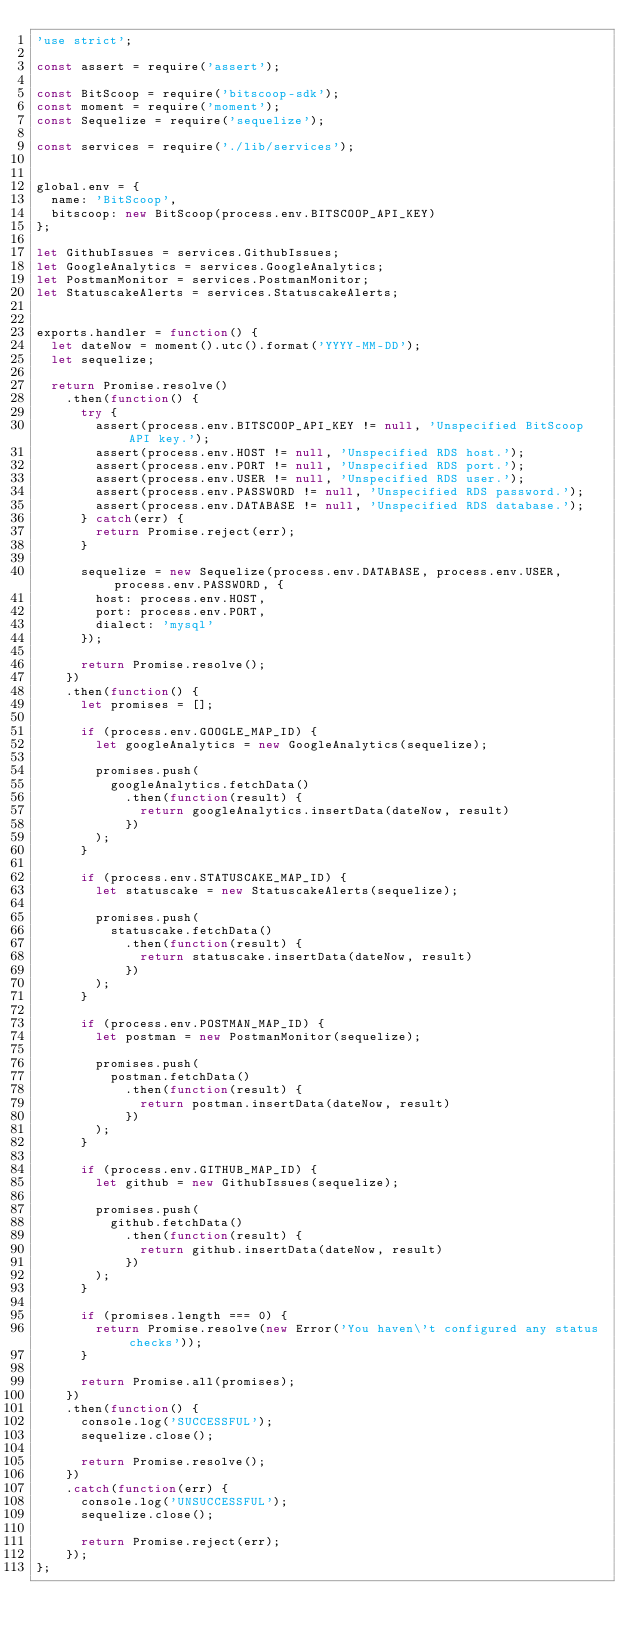<code> <loc_0><loc_0><loc_500><loc_500><_JavaScript_>'use strict';

const assert = require('assert');

const BitScoop = require('bitscoop-sdk');
const moment = require('moment');
const Sequelize = require('sequelize');

const services = require('./lib/services');


global.env = {
	name: 'BitScoop',
	bitscoop: new BitScoop(process.env.BITSCOOP_API_KEY)
};

let GithubIssues = services.GithubIssues;
let GoogleAnalytics = services.GoogleAnalytics;
let PostmanMonitor = services.PostmanMonitor;
let StatuscakeAlerts = services.StatuscakeAlerts;


exports.handler = function() {
	let dateNow = moment().utc().format('YYYY-MM-DD');
	let sequelize;

	return Promise.resolve()
		.then(function() {
			try {
				assert(process.env.BITSCOOP_API_KEY != null, 'Unspecified BitScoop API key.');
				assert(process.env.HOST != null, 'Unspecified RDS host.');
				assert(process.env.PORT != null, 'Unspecified RDS port.');
				assert(process.env.USER != null, 'Unspecified RDS user.');
				assert(process.env.PASSWORD != null, 'Unspecified RDS password.');
				assert(process.env.DATABASE != null, 'Unspecified RDS database.');
			} catch(err) {
				return Promise.reject(err);
			}

			sequelize = new Sequelize(process.env.DATABASE, process.env.USER, process.env.PASSWORD, {
				host: process.env.HOST,
				port: process.env.PORT,
				dialect: 'mysql'
			});

			return Promise.resolve();
		})
		.then(function() {
			let promises = [];

			if (process.env.GOOGLE_MAP_ID) {
				let googleAnalytics = new GoogleAnalytics(sequelize);

				promises.push(
					googleAnalytics.fetchData()
						.then(function(result) {
							return googleAnalytics.insertData(dateNow, result)
						})
				);
			}

			if (process.env.STATUSCAKE_MAP_ID) {
				let statuscake = new StatuscakeAlerts(sequelize);

				promises.push(
					statuscake.fetchData()
						.then(function(result) {
							return statuscake.insertData(dateNow, result)
						})
				);
			}

			if (process.env.POSTMAN_MAP_ID) {
				let postman = new PostmanMonitor(sequelize);

				promises.push(
					postman.fetchData()
						.then(function(result) {
							return postman.insertData(dateNow, result)
						})
				);
			}

			if (process.env.GITHUB_MAP_ID) {
				let github = new GithubIssues(sequelize);

				promises.push(
					github.fetchData()
						.then(function(result) {
							return github.insertData(dateNow, result)
						})
				);
			}

			if (promises.length === 0) {
				return Promise.resolve(new Error('You haven\'t configured any status checks'));
			}

			return Promise.all(promises);
		})
		.then(function() {
			console.log('SUCCESSFUL');
			sequelize.close();

			return Promise.resolve();
		})
		.catch(function(err) {
			console.log('UNSUCCESSFUL');
			sequelize.close();

			return Promise.reject(err);
		});
};
</code> 